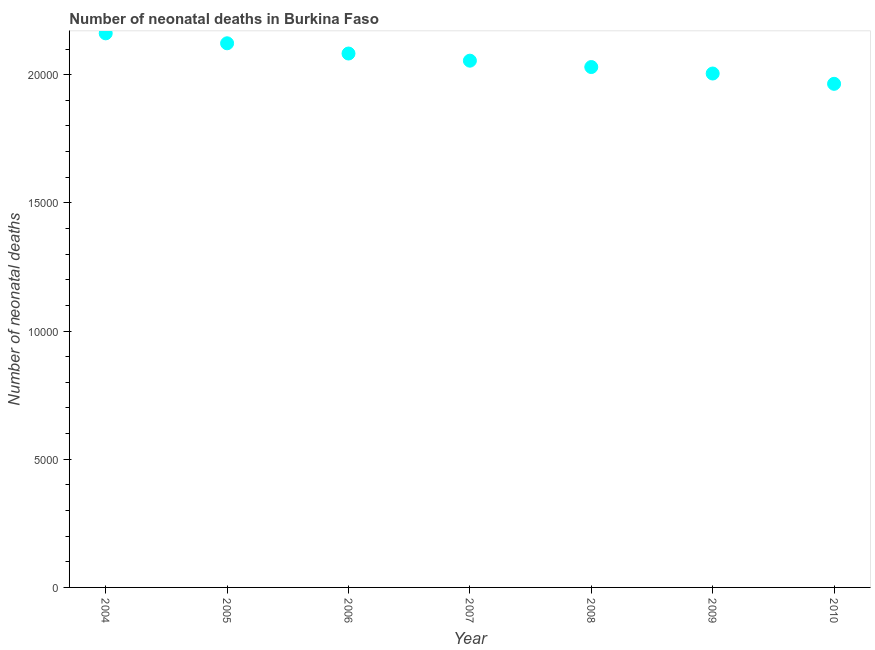What is the number of neonatal deaths in 2007?
Make the answer very short. 2.05e+04. Across all years, what is the maximum number of neonatal deaths?
Ensure brevity in your answer.  2.16e+04. Across all years, what is the minimum number of neonatal deaths?
Your answer should be very brief. 1.96e+04. What is the sum of the number of neonatal deaths?
Keep it short and to the point. 1.44e+05. What is the difference between the number of neonatal deaths in 2007 and 2008?
Provide a succinct answer. 248. What is the average number of neonatal deaths per year?
Provide a short and direct response. 2.06e+04. What is the median number of neonatal deaths?
Keep it short and to the point. 2.05e+04. What is the ratio of the number of neonatal deaths in 2007 to that in 2010?
Your response must be concise. 1.05. Is the number of neonatal deaths in 2004 less than that in 2008?
Your answer should be compact. No. Is the difference between the number of neonatal deaths in 2006 and 2007 greater than the difference between any two years?
Make the answer very short. No. What is the difference between the highest and the second highest number of neonatal deaths?
Make the answer very short. 388. Is the sum of the number of neonatal deaths in 2007 and 2009 greater than the maximum number of neonatal deaths across all years?
Your answer should be compact. Yes. What is the difference between the highest and the lowest number of neonatal deaths?
Keep it short and to the point. 1969. Does the number of neonatal deaths monotonically increase over the years?
Keep it short and to the point. No. How many dotlines are there?
Offer a very short reply. 1. How many years are there in the graph?
Offer a terse response. 7. What is the difference between two consecutive major ticks on the Y-axis?
Offer a terse response. 5000. Are the values on the major ticks of Y-axis written in scientific E-notation?
Keep it short and to the point. No. Does the graph contain any zero values?
Ensure brevity in your answer.  No. What is the title of the graph?
Keep it short and to the point. Number of neonatal deaths in Burkina Faso. What is the label or title of the X-axis?
Ensure brevity in your answer.  Year. What is the label or title of the Y-axis?
Offer a terse response. Number of neonatal deaths. What is the Number of neonatal deaths in 2004?
Offer a terse response. 2.16e+04. What is the Number of neonatal deaths in 2005?
Give a very brief answer. 2.12e+04. What is the Number of neonatal deaths in 2006?
Give a very brief answer. 2.08e+04. What is the Number of neonatal deaths in 2007?
Your answer should be compact. 2.05e+04. What is the Number of neonatal deaths in 2008?
Provide a succinct answer. 2.03e+04. What is the Number of neonatal deaths in 2009?
Keep it short and to the point. 2.00e+04. What is the Number of neonatal deaths in 2010?
Make the answer very short. 1.96e+04. What is the difference between the Number of neonatal deaths in 2004 and 2005?
Your response must be concise. 388. What is the difference between the Number of neonatal deaths in 2004 and 2006?
Offer a very short reply. 787. What is the difference between the Number of neonatal deaths in 2004 and 2007?
Your answer should be compact. 1066. What is the difference between the Number of neonatal deaths in 2004 and 2008?
Offer a terse response. 1314. What is the difference between the Number of neonatal deaths in 2004 and 2009?
Ensure brevity in your answer.  1567. What is the difference between the Number of neonatal deaths in 2004 and 2010?
Provide a succinct answer. 1969. What is the difference between the Number of neonatal deaths in 2005 and 2006?
Make the answer very short. 399. What is the difference between the Number of neonatal deaths in 2005 and 2007?
Offer a very short reply. 678. What is the difference between the Number of neonatal deaths in 2005 and 2008?
Your response must be concise. 926. What is the difference between the Number of neonatal deaths in 2005 and 2009?
Keep it short and to the point. 1179. What is the difference between the Number of neonatal deaths in 2005 and 2010?
Keep it short and to the point. 1581. What is the difference between the Number of neonatal deaths in 2006 and 2007?
Make the answer very short. 279. What is the difference between the Number of neonatal deaths in 2006 and 2008?
Your response must be concise. 527. What is the difference between the Number of neonatal deaths in 2006 and 2009?
Keep it short and to the point. 780. What is the difference between the Number of neonatal deaths in 2006 and 2010?
Provide a succinct answer. 1182. What is the difference between the Number of neonatal deaths in 2007 and 2008?
Ensure brevity in your answer.  248. What is the difference between the Number of neonatal deaths in 2007 and 2009?
Offer a terse response. 501. What is the difference between the Number of neonatal deaths in 2007 and 2010?
Provide a succinct answer. 903. What is the difference between the Number of neonatal deaths in 2008 and 2009?
Ensure brevity in your answer.  253. What is the difference between the Number of neonatal deaths in 2008 and 2010?
Provide a short and direct response. 655. What is the difference between the Number of neonatal deaths in 2009 and 2010?
Ensure brevity in your answer.  402. What is the ratio of the Number of neonatal deaths in 2004 to that in 2006?
Your answer should be compact. 1.04. What is the ratio of the Number of neonatal deaths in 2004 to that in 2007?
Provide a succinct answer. 1.05. What is the ratio of the Number of neonatal deaths in 2004 to that in 2008?
Ensure brevity in your answer.  1.06. What is the ratio of the Number of neonatal deaths in 2004 to that in 2009?
Make the answer very short. 1.08. What is the ratio of the Number of neonatal deaths in 2004 to that in 2010?
Offer a very short reply. 1.1. What is the ratio of the Number of neonatal deaths in 2005 to that in 2007?
Offer a terse response. 1.03. What is the ratio of the Number of neonatal deaths in 2005 to that in 2008?
Ensure brevity in your answer.  1.05. What is the ratio of the Number of neonatal deaths in 2005 to that in 2009?
Make the answer very short. 1.06. What is the ratio of the Number of neonatal deaths in 2006 to that in 2007?
Make the answer very short. 1.01. What is the ratio of the Number of neonatal deaths in 2006 to that in 2008?
Your answer should be very brief. 1.03. What is the ratio of the Number of neonatal deaths in 2006 to that in 2009?
Offer a terse response. 1.04. What is the ratio of the Number of neonatal deaths in 2006 to that in 2010?
Provide a short and direct response. 1.06. What is the ratio of the Number of neonatal deaths in 2007 to that in 2008?
Provide a succinct answer. 1.01. What is the ratio of the Number of neonatal deaths in 2007 to that in 2009?
Your response must be concise. 1.02. What is the ratio of the Number of neonatal deaths in 2007 to that in 2010?
Your response must be concise. 1.05. What is the ratio of the Number of neonatal deaths in 2008 to that in 2010?
Keep it short and to the point. 1.03. What is the ratio of the Number of neonatal deaths in 2009 to that in 2010?
Your response must be concise. 1.02. 